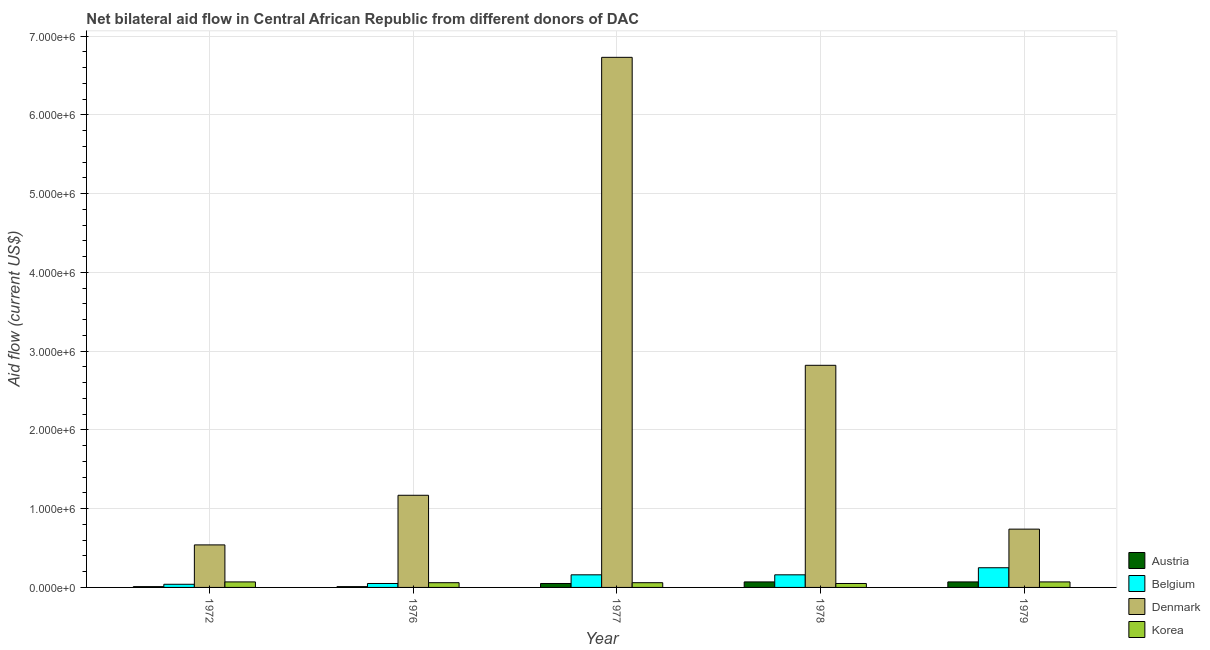How many different coloured bars are there?
Provide a short and direct response. 4. Are the number of bars per tick equal to the number of legend labels?
Ensure brevity in your answer.  Yes. Are the number of bars on each tick of the X-axis equal?
Offer a terse response. Yes. What is the label of the 5th group of bars from the left?
Keep it short and to the point. 1979. What is the amount of aid given by denmark in 1979?
Keep it short and to the point. 7.40e+05. Across all years, what is the maximum amount of aid given by korea?
Your answer should be compact. 7.00e+04. Across all years, what is the minimum amount of aid given by denmark?
Ensure brevity in your answer.  5.40e+05. In which year was the amount of aid given by denmark maximum?
Keep it short and to the point. 1977. In which year was the amount of aid given by denmark minimum?
Your answer should be compact. 1972. What is the total amount of aid given by belgium in the graph?
Make the answer very short. 6.60e+05. What is the difference between the amount of aid given by korea in 1977 and that in 1978?
Make the answer very short. 10000. What is the difference between the amount of aid given by austria in 1978 and the amount of aid given by denmark in 1972?
Keep it short and to the point. 6.00e+04. What is the average amount of aid given by korea per year?
Offer a terse response. 6.20e+04. In the year 1976, what is the difference between the amount of aid given by belgium and amount of aid given by austria?
Ensure brevity in your answer.  0. What is the ratio of the amount of aid given by austria in 1972 to that in 1978?
Provide a succinct answer. 0.14. Is the difference between the amount of aid given by korea in 1976 and 1979 greater than the difference between the amount of aid given by denmark in 1976 and 1979?
Offer a terse response. No. What is the difference between the highest and the lowest amount of aid given by denmark?
Provide a short and direct response. 6.19e+06. Is it the case that in every year, the sum of the amount of aid given by austria and amount of aid given by belgium is greater than the sum of amount of aid given by korea and amount of aid given by denmark?
Provide a succinct answer. No. What does the 2nd bar from the left in 1972 represents?
Offer a very short reply. Belgium. Is it the case that in every year, the sum of the amount of aid given by austria and amount of aid given by belgium is greater than the amount of aid given by denmark?
Keep it short and to the point. No. Are all the bars in the graph horizontal?
Give a very brief answer. No. Are the values on the major ticks of Y-axis written in scientific E-notation?
Your answer should be compact. Yes. Does the graph contain any zero values?
Offer a very short reply. No. Does the graph contain grids?
Your answer should be very brief. Yes. How many legend labels are there?
Make the answer very short. 4. How are the legend labels stacked?
Provide a succinct answer. Vertical. What is the title of the graph?
Provide a short and direct response. Net bilateral aid flow in Central African Republic from different donors of DAC. What is the label or title of the X-axis?
Your answer should be compact. Year. What is the label or title of the Y-axis?
Provide a succinct answer. Aid flow (current US$). What is the Aid flow (current US$) in Belgium in 1972?
Your response must be concise. 4.00e+04. What is the Aid flow (current US$) in Denmark in 1972?
Ensure brevity in your answer.  5.40e+05. What is the Aid flow (current US$) in Austria in 1976?
Your response must be concise. 10000. What is the Aid flow (current US$) of Denmark in 1976?
Your answer should be compact. 1.17e+06. What is the Aid flow (current US$) in Korea in 1976?
Provide a succinct answer. 6.00e+04. What is the Aid flow (current US$) in Austria in 1977?
Your response must be concise. 5.00e+04. What is the Aid flow (current US$) in Denmark in 1977?
Offer a very short reply. 6.73e+06. What is the Aid flow (current US$) of Denmark in 1978?
Give a very brief answer. 2.82e+06. What is the Aid flow (current US$) of Korea in 1978?
Offer a terse response. 5.00e+04. What is the Aid flow (current US$) of Austria in 1979?
Give a very brief answer. 7.00e+04. What is the Aid flow (current US$) in Denmark in 1979?
Make the answer very short. 7.40e+05. Across all years, what is the maximum Aid flow (current US$) in Austria?
Your answer should be compact. 7.00e+04. Across all years, what is the maximum Aid flow (current US$) of Belgium?
Offer a terse response. 2.50e+05. Across all years, what is the maximum Aid flow (current US$) of Denmark?
Provide a short and direct response. 6.73e+06. Across all years, what is the minimum Aid flow (current US$) in Belgium?
Your answer should be very brief. 4.00e+04. Across all years, what is the minimum Aid flow (current US$) of Denmark?
Provide a short and direct response. 5.40e+05. What is the difference between the Aid flow (current US$) in Austria in 1972 and that in 1976?
Give a very brief answer. 0. What is the difference between the Aid flow (current US$) of Belgium in 1972 and that in 1976?
Provide a short and direct response. -10000. What is the difference between the Aid flow (current US$) in Denmark in 1972 and that in 1976?
Offer a terse response. -6.30e+05. What is the difference between the Aid flow (current US$) of Korea in 1972 and that in 1976?
Provide a succinct answer. 10000. What is the difference between the Aid flow (current US$) in Belgium in 1972 and that in 1977?
Your answer should be compact. -1.20e+05. What is the difference between the Aid flow (current US$) in Denmark in 1972 and that in 1977?
Offer a terse response. -6.19e+06. What is the difference between the Aid flow (current US$) in Austria in 1972 and that in 1978?
Offer a very short reply. -6.00e+04. What is the difference between the Aid flow (current US$) of Belgium in 1972 and that in 1978?
Provide a succinct answer. -1.20e+05. What is the difference between the Aid flow (current US$) in Denmark in 1972 and that in 1978?
Offer a terse response. -2.28e+06. What is the difference between the Aid flow (current US$) in Korea in 1972 and that in 1978?
Keep it short and to the point. 2.00e+04. What is the difference between the Aid flow (current US$) in Austria in 1972 and that in 1979?
Your answer should be compact. -6.00e+04. What is the difference between the Aid flow (current US$) in Denmark in 1972 and that in 1979?
Your answer should be very brief. -2.00e+05. What is the difference between the Aid flow (current US$) of Belgium in 1976 and that in 1977?
Ensure brevity in your answer.  -1.10e+05. What is the difference between the Aid flow (current US$) of Denmark in 1976 and that in 1977?
Offer a very short reply. -5.56e+06. What is the difference between the Aid flow (current US$) of Austria in 1976 and that in 1978?
Offer a very short reply. -6.00e+04. What is the difference between the Aid flow (current US$) in Belgium in 1976 and that in 1978?
Offer a terse response. -1.10e+05. What is the difference between the Aid flow (current US$) in Denmark in 1976 and that in 1978?
Offer a very short reply. -1.65e+06. What is the difference between the Aid flow (current US$) of Austria in 1976 and that in 1979?
Offer a terse response. -6.00e+04. What is the difference between the Aid flow (current US$) in Denmark in 1976 and that in 1979?
Your answer should be compact. 4.30e+05. What is the difference between the Aid flow (current US$) of Austria in 1977 and that in 1978?
Offer a terse response. -2.00e+04. What is the difference between the Aid flow (current US$) in Belgium in 1977 and that in 1978?
Make the answer very short. 0. What is the difference between the Aid flow (current US$) in Denmark in 1977 and that in 1978?
Offer a very short reply. 3.91e+06. What is the difference between the Aid flow (current US$) of Belgium in 1977 and that in 1979?
Offer a terse response. -9.00e+04. What is the difference between the Aid flow (current US$) in Denmark in 1977 and that in 1979?
Provide a succinct answer. 5.99e+06. What is the difference between the Aid flow (current US$) of Belgium in 1978 and that in 1979?
Offer a terse response. -9.00e+04. What is the difference between the Aid flow (current US$) of Denmark in 1978 and that in 1979?
Your answer should be very brief. 2.08e+06. What is the difference between the Aid flow (current US$) of Austria in 1972 and the Aid flow (current US$) of Belgium in 1976?
Offer a very short reply. -4.00e+04. What is the difference between the Aid flow (current US$) in Austria in 1972 and the Aid flow (current US$) in Denmark in 1976?
Provide a short and direct response. -1.16e+06. What is the difference between the Aid flow (current US$) in Belgium in 1972 and the Aid flow (current US$) in Denmark in 1976?
Ensure brevity in your answer.  -1.13e+06. What is the difference between the Aid flow (current US$) in Austria in 1972 and the Aid flow (current US$) in Denmark in 1977?
Give a very brief answer. -6.72e+06. What is the difference between the Aid flow (current US$) of Belgium in 1972 and the Aid flow (current US$) of Denmark in 1977?
Make the answer very short. -6.69e+06. What is the difference between the Aid flow (current US$) of Austria in 1972 and the Aid flow (current US$) of Denmark in 1978?
Provide a succinct answer. -2.81e+06. What is the difference between the Aid flow (current US$) in Belgium in 1972 and the Aid flow (current US$) in Denmark in 1978?
Give a very brief answer. -2.78e+06. What is the difference between the Aid flow (current US$) in Austria in 1972 and the Aid flow (current US$) in Denmark in 1979?
Keep it short and to the point. -7.30e+05. What is the difference between the Aid flow (current US$) in Belgium in 1972 and the Aid flow (current US$) in Denmark in 1979?
Ensure brevity in your answer.  -7.00e+05. What is the difference between the Aid flow (current US$) of Austria in 1976 and the Aid flow (current US$) of Denmark in 1977?
Your answer should be compact. -6.72e+06. What is the difference between the Aid flow (current US$) of Belgium in 1976 and the Aid flow (current US$) of Denmark in 1977?
Give a very brief answer. -6.68e+06. What is the difference between the Aid flow (current US$) of Denmark in 1976 and the Aid flow (current US$) of Korea in 1977?
Keep it short and to the point. 1.11e+06. What is the difference between the Aid flow (current US$) in Austria in 1976 and the Aid flow (current US$) in Belgium in 1978?
Make the answer very short. -1.50e+05. What is the difference between the Aid flow (current US$) of Austria in 1976 and the Aid flow (current US$) of Denmark in 1978?
Make the answer very short. -2.81e+06. What is the difference between the Aid flow (current US$) in Belgium in 1976 and the Aid flow (current US$) in Denmark in 1978?
Offer a very short reply. -2.77e+06. What is the difference between the Aid flow (current US$) of Denmark in 1976 and the Aid flow (current US$) of Korea in 1978?
Offer a terse response. 1.12e+06. What is the difference between the Aid flow (current US$) in Austria in 1976 and the Aid flow (current US$) in Denmark in 1979?
Your answer should be compact. -7.30e+05. What is the difference between the Aid flow (current US$) in Austria in 1976 and the Aid flow (current US$) in Korea in 1979?
Give a very brief answer. -6.00e+04. What is the difference between the Aid flow (current US$) of Belgium in 1976 and the Aid flow (current US$) of Denmark in 1979?
Ensure brevity in your answer.  -6.90e+05. What is the difference between the Aid flow (current US$) in Belgium in 1976 and the Aid flow (current US$) in Korea in 1979?
Give a very brief answer. -2.00e+04. What is the difference between the Aid flow (current US$) of Denmark in 1976 and the Aid flow (current US$) of Korea in 1979?
Give a very brief answer. 1.10e+06. What is the difference between the Aid flow (current US$) in Austria in 1977 and the Aid flow (current US$) in Denmark in 1978?
Offer a very short reply. -2.77e+06. What is the difference between the Aid flow (current US$) in Belgium in 1977 and the Aid flow (current US$) in Denmark in 1978?
Keep it short and to the point. -2.66e+06. What is the difference between the Aid flow (current US$) in Belgium in 1977 and the Aid flow (current US$) in Korea in 1978?
Your answer should be very brief. 1.10e+05. What is the difference between the Aid flow (current US$) in Denmark in 1977 and the Aid flow (current US$) in Korea in 1978?
Offer a terse response. 6.68e+06. What is the difference between the Aid flow (current US$) in Austria in 1977 and the Aid flow (current US$) in Denmark in 1979?
Provide a succinct answer. -6.90e+05. What is the difference between the Aid flow (current US$) in Austria in 1977 and the Aid flow (current US$) in Korea in 1979?
Keep it short and to the point. -2.00e+04. What is the difference between the Aid flow (current US$) of Belgium in 1977 and the Aid flow (current US$) of Denmark in 1979?
Your answer should be compact. -5.80e+05. What is the difference between the Aid flow (current US$) in Belgium in 1977 and the Aid flow (current US$) in Korea in 1979?
Give a very brief answer. 9.00e+04. What is the difference between the Aid flow (current US$) of Denmark in 1977 and the Aid flow (current US$) of Korea in 1979?
Offer a terse response. 6.66e+06. What is the difference between the Aid flow (current US$) of Austria in 1978 and the Aid flow (current US$) of Denmark in 1979?
Offer a terse response. -6.70e+05. What is the difference between the Aid flow (current US$) in Belgium in 1978 and the Aid flow (current US$) in Denmark in 1979?
Your answer should be compact. -5.80e+05. What is the difference between the Aid flow (current US$) of Belgium in 1978 and the Aid flow (current US$) of Korea in 1979?
Give a very brief answer. 9.00e+04. What is the difference between the Aid flow (current US$) in Denmark in 1978 and the Aid flow (current US$) in Korea in 1979?
Your answer should be very brief. 2.75e+06. What is the average Aid flow (current US$) in Austria per year?
Make the answer very short. 4.20e+04. What is the average Aid flow (current US$) of Belgium per year?
Keep it short and to the point. 1.32e+05. What is the average Aid flow (current US$) of Denmark per year?
Make the answer very short. 2.40e+06. What is the average Aid flow (current US$) of Korea per year?
Your response must be concise. 6.20e+04. In the year 1972, what is the difference between the Aid flow (current US$) in Austria and Aid flow (current US$) in Denmark?
Ensure brevity in your answer.  -5.30e+05. In the year 1972, what is the difference between the Aid flow (current US$) of Belgium and Aid flow (current US$) of Denmark?
Your answer should be very brief. -5.00e+05. In the year 1972, what is the difference between the Aid flow (current US$) in Belgium and Aid flow (current US$) in Korea?
Make the answer very short. -3.00e+04. In the year 1976, what is the difference between the Aid flow (current US$) of Austria and Aid flow (current US$) of Belgium?
Give a very brief answer. -4.00e+04. In the year 1976, what is the difference between the Aid flow (current US$) in Austria and Aid flow (current US$) in Denmark?
Give a very brief answer. -1.16e+06. In the year 1976, what is the difference between the Aid flow (current US$) in Belgium and Aid flow (current US$) in Denmark?
Provide a succinct answer. -1.12e+06. In the year 1976, what is the difference between the Aid flow (current US$) in Belgium and Aid flow (current US$) in Korea?
Your response must be concise. -10000. In the year 1976, what is the difference between the Aid flow (current US$) of Denmark and Aid flow (current US$) of Korea?
Offer a terse response. 1.11e+06. In the year 1977, what is the difference between the Aid flow (current US$) of Austria and Aid flow (current US$) of Belgium?
Your response must be concise. -1.10e+05. In the year 1977, what is the difference between the Aid flow (current US$) in Austria and Aid flow (current US$) in Denmark?
Give a very brief answer. -6.68e+06. In the year 1977, what is the difference between the Aid flow (current US$) of Belgium and Aid flow (current US$) of Denmark?
Keep it short and to the point. -6.57e+06. In the year 1977, what is the difference between the Aid flow (current US$) in Belgium and Aid flow (current US$) in Korea?
Your answer should be compact. 1.00e+05. In the year 1977, what is the difference between the Aid flow (current US$) of Denmark and Aid flow (current US$) of Korea?
Give a very brief answer. 6.67e+06. In the year 1978, what is the difference between the Aid flow (current US$) of Austria and Aid flow (current US$) of Belgium?
Provide a short and direct response. -9.00e+04. In the year 1978, what is the difference between the Aid flow (current US$) in Austria and Aid flow (current US$) in Denmark?
Ensure brevity in your answer.  -2.75e+06. In the year 1978, what is the difference between the Aid flow (current US$) in Austria and Aid flow (current US$) in Korea?
Make the answer very short. 2.00e+04. In the year 1978, what is the difference between the Aid flow (current US$) of Belgium and Aid flow (current US$) of Denmark?
Offer a terse response. -2.66e+06. In the year 1978, what is the difference between the Aid flow (current US$) of Denmark and Aid flow (current US$) of Korea?
Offer a terse response. 2.77e+06. In the year 1979, what is the difference between the Aid flow (current US$) in Austria and Aid flow (current US$) in Denmark?
Give a very brief answer. -6.70e+05. In the year 1979, what is the difference between the Aid flow (current US$) of Austria and Aid flow (current US$) of Korea?
Provide a short and direct response. 0. In the year 1979, what is the difference between the Aid flow (current US$) of Belgium and Aid flow (current US$) of Denmark?
Keep it short and to the point. -4.90e+05. In the year 1979, what is the difference between the Aid flow (current US$) of Belgium and Aid flow (current US$) of Korea?
Your response must be concise. 1.80e+05. In the year 1979, what is the difference between the Aid flow (current US$) in Denmark and Aid flow (current US$) in Korea?
Offer a very short reply. 6.70e+05. What is the ratio of the Aid flow (current US$) in Denmark in 1972 to that in 1976?
Give a very brief answer. 0.46. What is the ratio of the Aid flow (current US$) of Korea in 1972 to that in 1976?
Make the answer very short. 1.17. What is the ratio of the Aid flow (current US$) in Denmark in 1972 to that in 1977?
Provide a short and direct response. 0.08. What is the ratio of the Aid flow (current US$) of Korea in 1972 to that in 1977?
Ensure brevity in your answer.  1.17. What is the ratio of the Aid flow (current US$) in Austria in 1972 to that in 1978?
Give a very brief answer. 0.14. What is the ratio of the Aid flow (current US$) of Denmark in 1972 to that in 1978?
Give a very brief answer. 0.19. What is the ratio of the Aid flow (current US$) of Austria in 1972 to that in 1979?
Make the answer very short. 0.14. What is the ratio of the Aid flow (current US$) of Belgium in 1972 to that in 1979?
Offer a terse response. 0.16. What is the ratio of the Aid flow (current US$) in Denmark in 1972 to that in 1979?
Give a very brief answer. 0.73. What is the ratio of the Aid flow (current US$) in Korea in 1972 to that in 1979?
Provide a short and direct response. 1. What is the ratio of the Aid flow (current US$) in Austria in 1976 to that in 1977?
Provide a succinct answer. 0.2. What is the ratio of the Aid flow (current US$) of Belgium in 1976 to that in 1977?
Your response must be concise. 0.31. What is the ratio of the Aid flow (current US$) of Denmark in 1976 to that in 1977?
Provide a succinct answer. 0.17. What is the ratio of the Aid flow (current US$) of Austria in 1976 to that in 1978?
Provide a succinct answer. 0.14. What is the ratio of the Aid flow (current US$) of Belgium in 1976 to that in 1978?
Keep it short and to the point. 0.31. What is the ratio of the Aid flow (current US$) in Denmark in 1976 to that in 1978?
Offer a terse response. 0.41. What is the ratio of the Aid flow (current US$) of Austria in 1976 to that in 1979?
Give a very brief answer. 0.14. What is the ratio of the Aid flow (current US$) of Denmark in 1976 to that in 1979?
Your response must be concise. 1.58. What is the ratio of the Aid flow (current US$) in Denmark in 1977 to that in 1978?
Ensure brevity in your answer.  2.39. What is the ratio of the Aid flow (current US$) of Korea in 1977 to that in 1978?
Ensure brevity in your answer.  1.2. What is the ratio of the Aid flow (current US$) in Austria in 1977 to that in 1979?
Your answer should be compact. 0.71. What is the ratio of the Aid flow (current US$) in Belgium in 1977 to that in 1979?
Your answer should be compact. 0.64. What is the ratio of the Aid flow (current US$) in Denmark in 1977 to that in 1979?
Ensure brevity in your answer.  9.09. What is the ratio of the Aid flow (current US$) in Austria in 1978 to that in 1979?
Give a very brief answer. 1. What is the ratio of the Aid flow (current US$) in Belgium in 1978 to that in 1979?
Offer a very short reply. 0.64. What is the ratio of the Aid flow (current US$) of Denmark in 1978 to that in 1979?
Give a very brief answer. 3.81. What is the difference between the highest and the second highest Aid flow (current US$) of Austria?
Offer a very short reply. 0. What is the difference between the highest and the second highest Aid flow (current US$) of Denmark?
Offer a terse response. 3.91e+06. What is the difference between the highest and the second highest Aid flow (current US$) of Korea?
Your answer should be compact. 0. What is the difference between the highest and the lowest Aid flow (current US$) in Austria?
Keep it short and to the point. 6.00e+04. What is the difference between the highest and the lowest Aid flow (current US$) of Denmark?
Provide a succinct answer. 6.19e+06. 